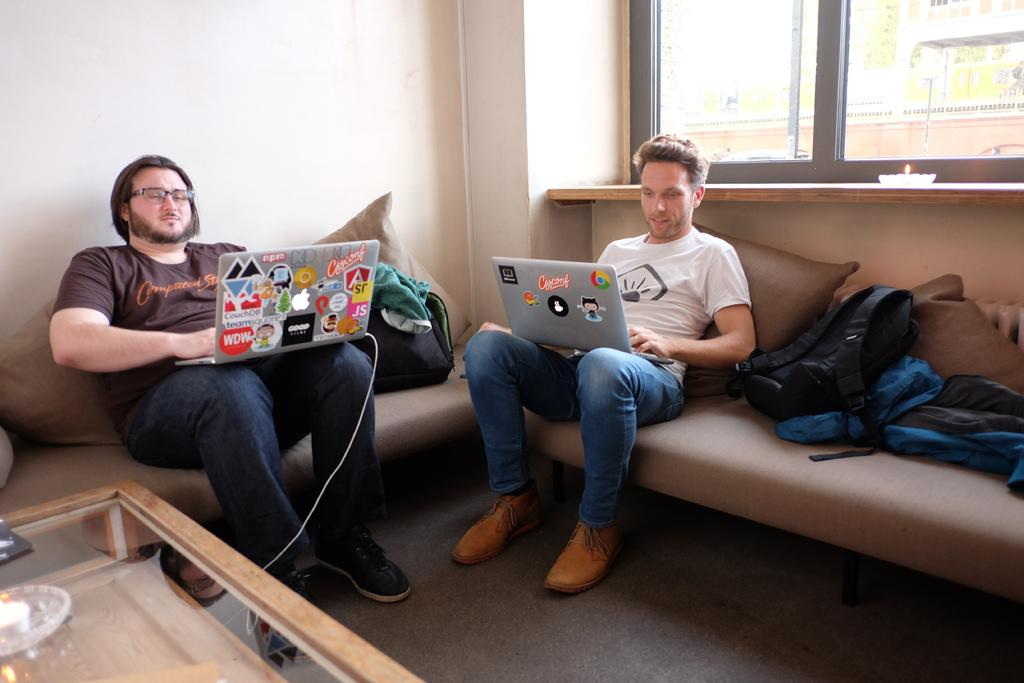What type of room is shown in the image? The image depicts a living room. What are the two persons in the living room doing? The persons are sitting on a sofa and working with a laptop. What else can be seen on the sofa besides the persons? There are bags on the sofa. What type of land can be seen through the window in the image? There is no window or land visible in the image; it only shows a living room with two persons on a sofa. Are there any police officers present in the image? No, there are no police officers present in the image. 